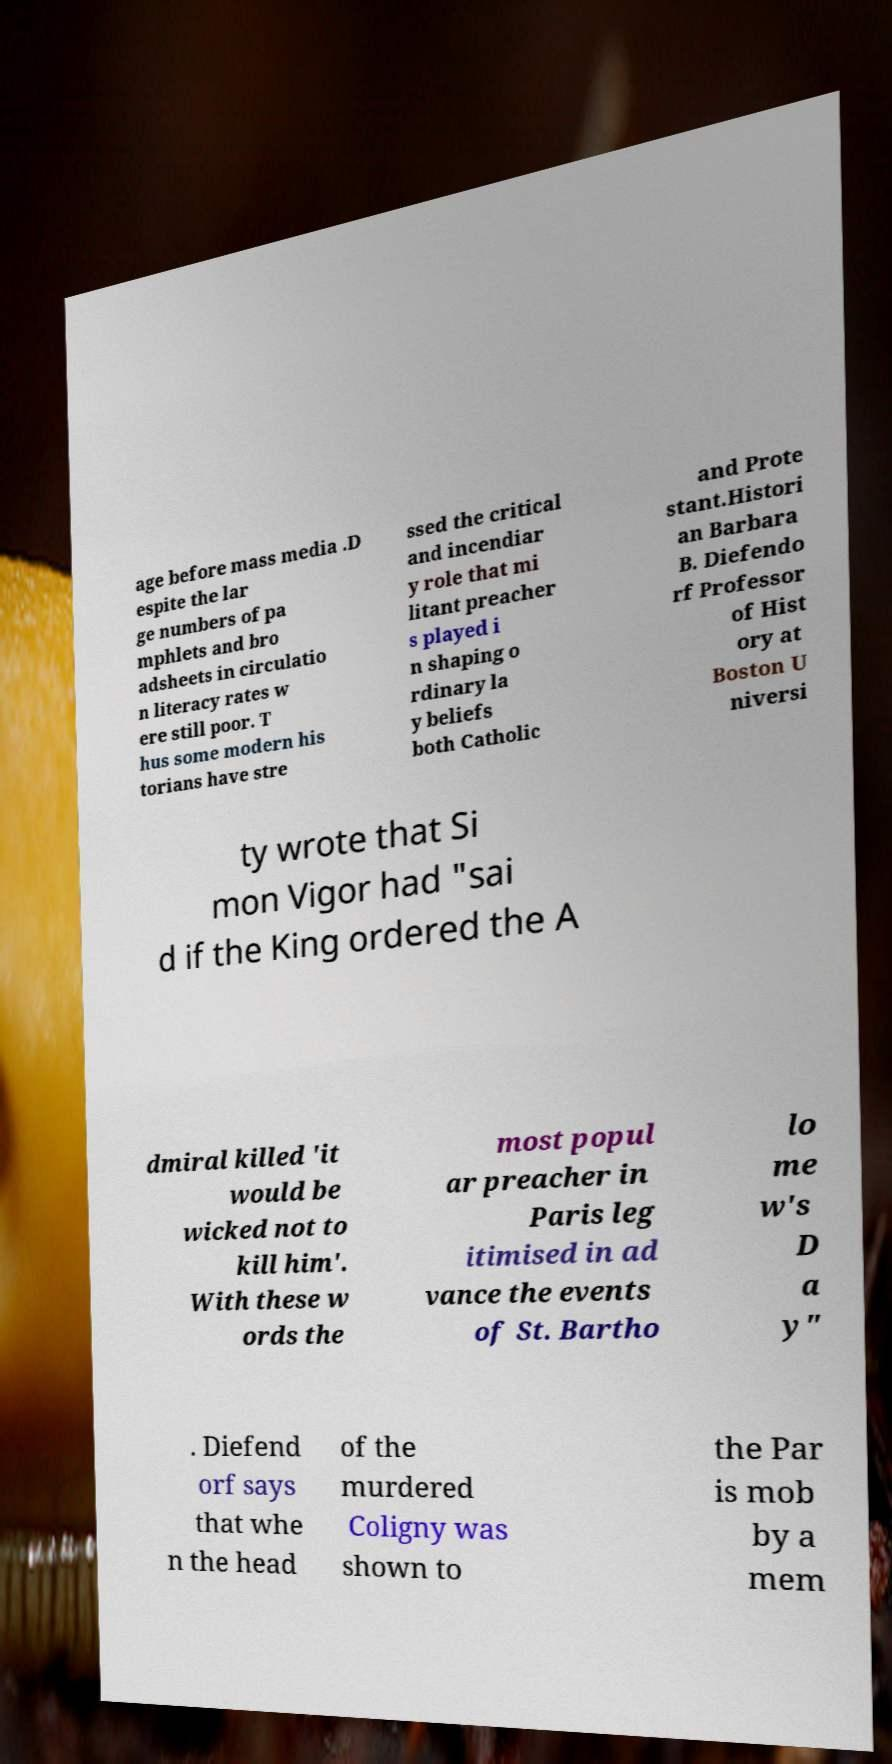Please read and relay the text visible in this image. What does it say? age before mass media .D espite the lar ge numbers of pa mphlets and bro adsheets in circulatio n literacy rates w ere still poor. T hus some modern his torians have stre ssed the critical and incendiar y role that mi litant preacher s played i n shaping o rdinary la y beliefs both Catholic and Prote stant.Histori an Barbara B. Diefendo rf Professor of Hist ory at Boston U niversi ty wrote that Si mon Vigor had "sai d if the King ordered the A dmiral killed 'it would be wicked not to kill him'. With these w ords the most popul ar preacher in Paris leg itimised in ad vance the events of St. Bartho lo me w's D a y" . Diefend orf says that whe n the head of the murdered Coligny was shown to the Par is mob by a mem 